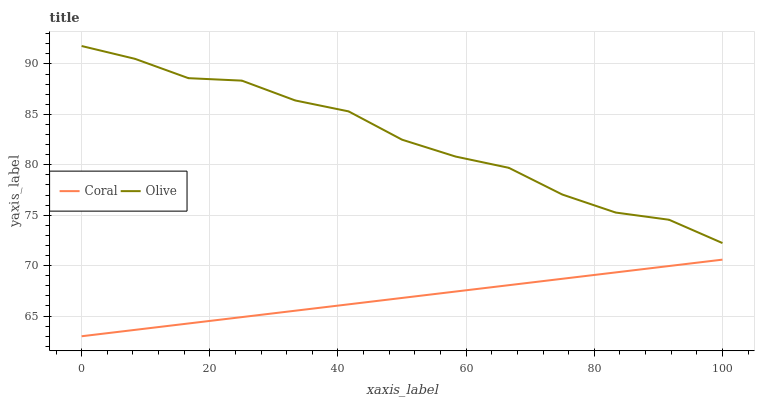Does Coral have the maximum area under the curve?
Answer yes or no. No. Is Coral the roughest?
Answer yes or no. No. Does Coral have the highest value?
Answer yes or no. No. Is Coral less than Olive?
Answer yes or no. Yes. Is Olive greater than Coral?
Answer yes or no. Yes. Does Coral intersect Olive?
Answer yes or no. No. 